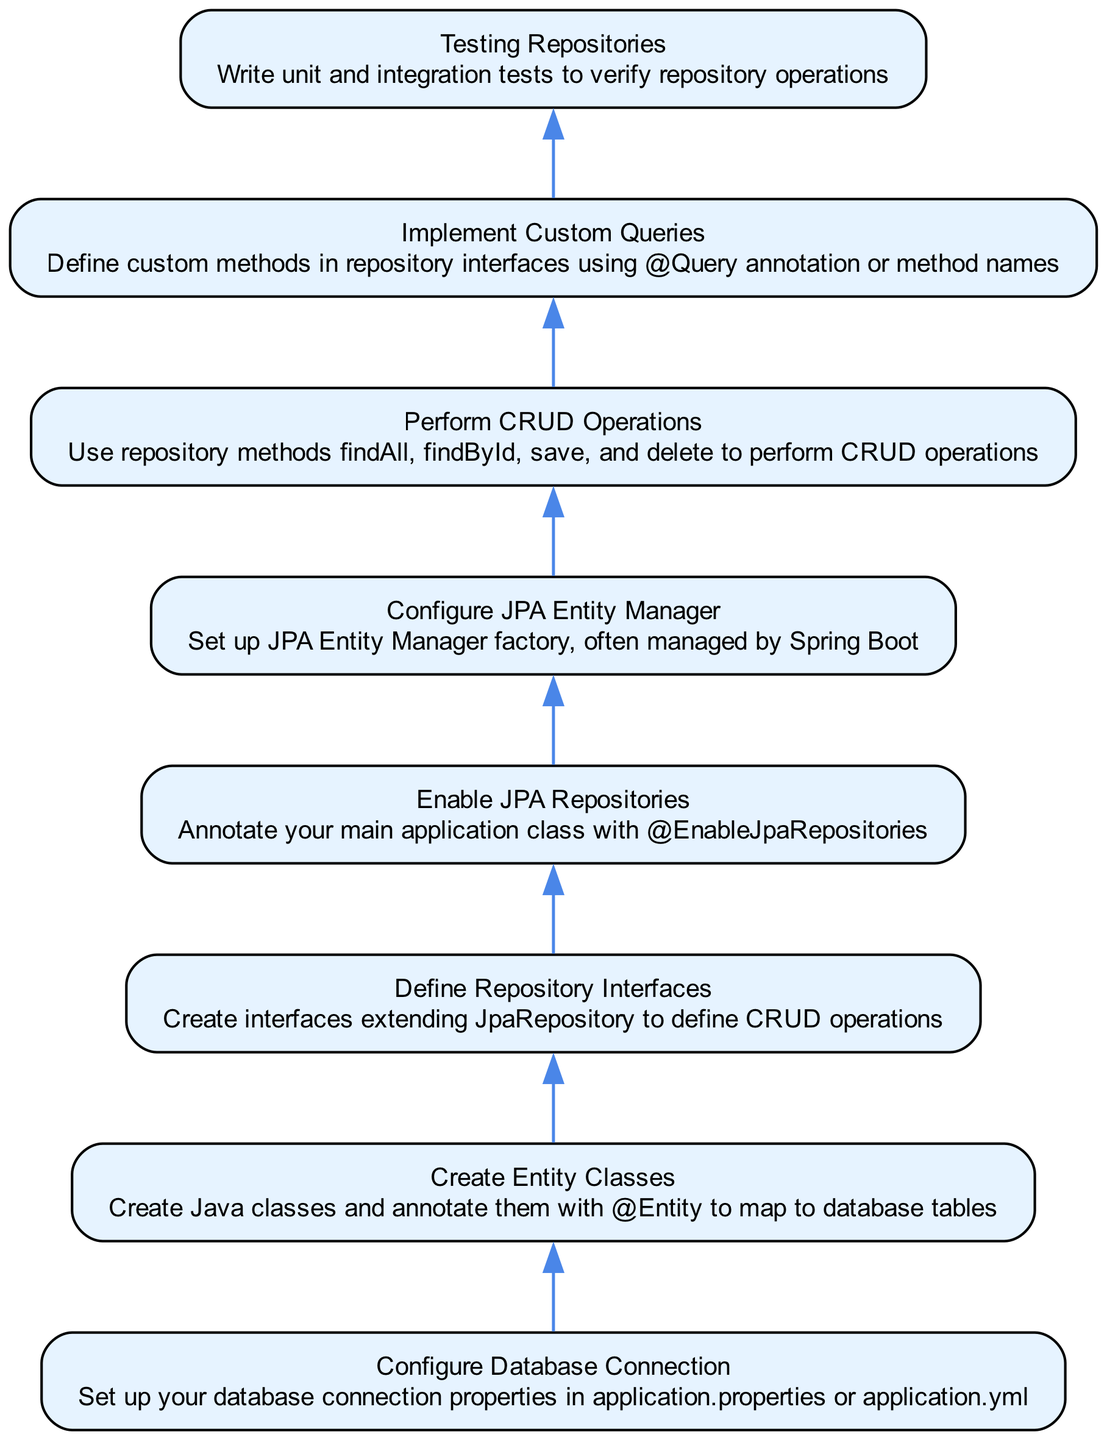What is the first step in building a Spring Data JPA repository? The diagram shows that the first step is "Configure Database Connection," indicating the initial action required in the process.
Answer: Configure Database Connection How many steps are there in the diagram? By counting the nodes in the flow chart, I identify a total of 8 steps that represent the process of building a Spring Data JPA repository.
Answer: 8 What step comes immediately after creating entity classes? According to the diagram, the step "Define Repository Interfaces" follows "Create Entity Classes," indicating the next action in the flow.
Answer: Define Repository Interfaces Which step involves the use of annotation for custom queries? The diagram specifically mentions that "Implement Custom Queries" is the step where repository interfaces include methods using the @Query annotation or method names.
Answer: Implement Custom Queries If JPA Entity Manager is configured, what step must precede it? The diagram illustrates that "Enable JPA Repositories" must occur before configuring the JPA Entity Manager, as shown by the direct connection in the flow from one step to the next.
Answer: Enable JPA Repositories Why is the "Testing Repositories" step significant? The "Testing Repositories" step includes writing unit and integration tests, emphasizing the importance of verifying the functionality of the repository after all other steps have been completed.
Answer: Verification of repository operations What action follows performing CRUD operations in the flow? Following the "Perform CRUD Operations" step in the diagram, the next action is to "Implement Custom Queries," indicating a transition from standard operations to custom implementations.
Answer: Implement Custom Queries What is the last step in building a Spring Data JPA repository? The final step in the diagram is "Testing Repositories," which suggests it is crucial to validate the functionality of the repository before considering it complete.
Answer: Testing Repositories 